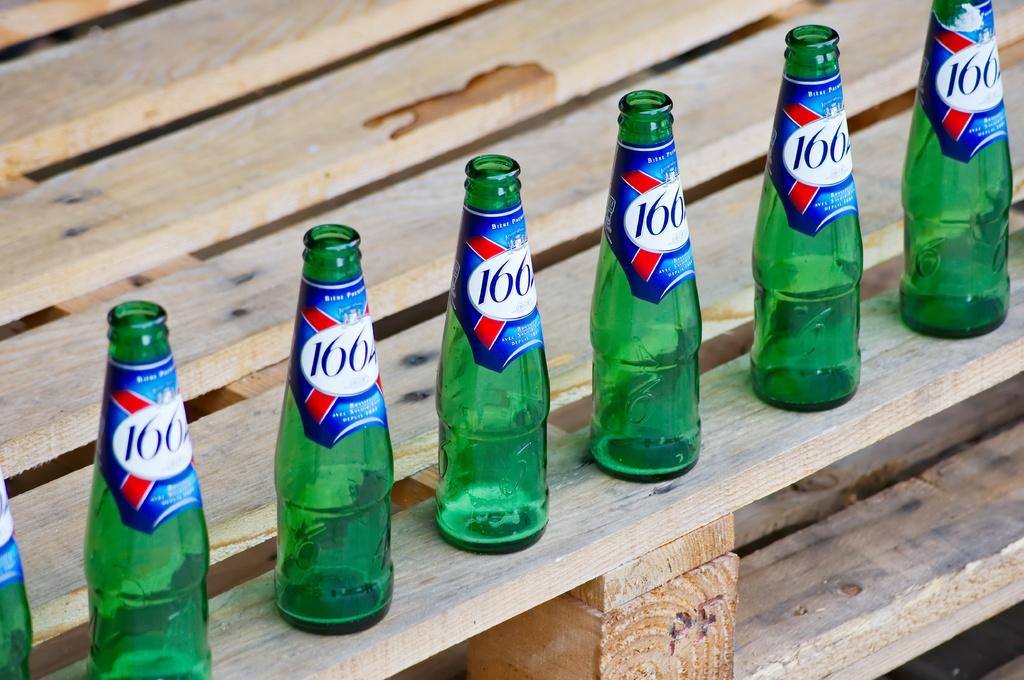How many calories are in the green bottled drink?
Your answer should be very brief. Unanswerable. Is the name of this 166?
Offer a terse response. Yes. 